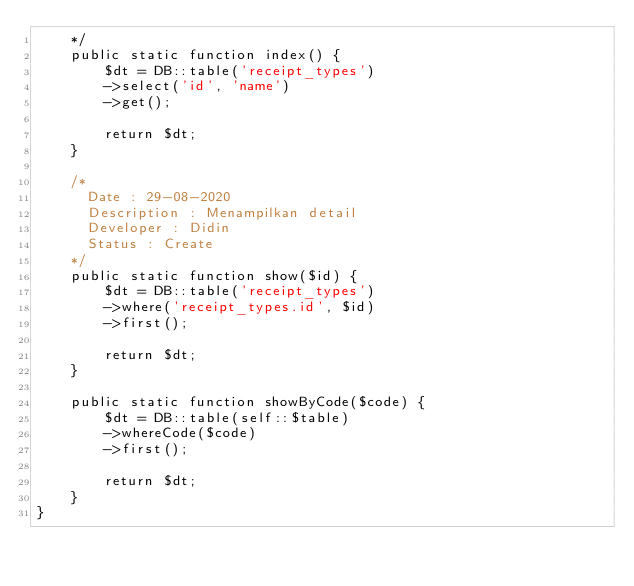<code> <loc_0><loc_0><loc_500><loc_500><_PHP_>    */
    public static function index() {
        $dt = DB::table('receipt_types')
        ->select('id', 'name')
        ->get();

        return $dt;
    }

    /*
      Date : 29-08-2020
      Description : Menampilkan detail 
      Developer : Didin
      Status : Create
    */
    public static function show($id) {
        $dt = DB::table('receipt_types')
        ->where('receipt_types.id', $id)
        ->first();

        return $dt;
    }

    public static function showByCode($code) {
        $dt = DB::table(self::$table)
        ->whereCode($code)
        ->first();

        return $dt;
    }
}
</code> 